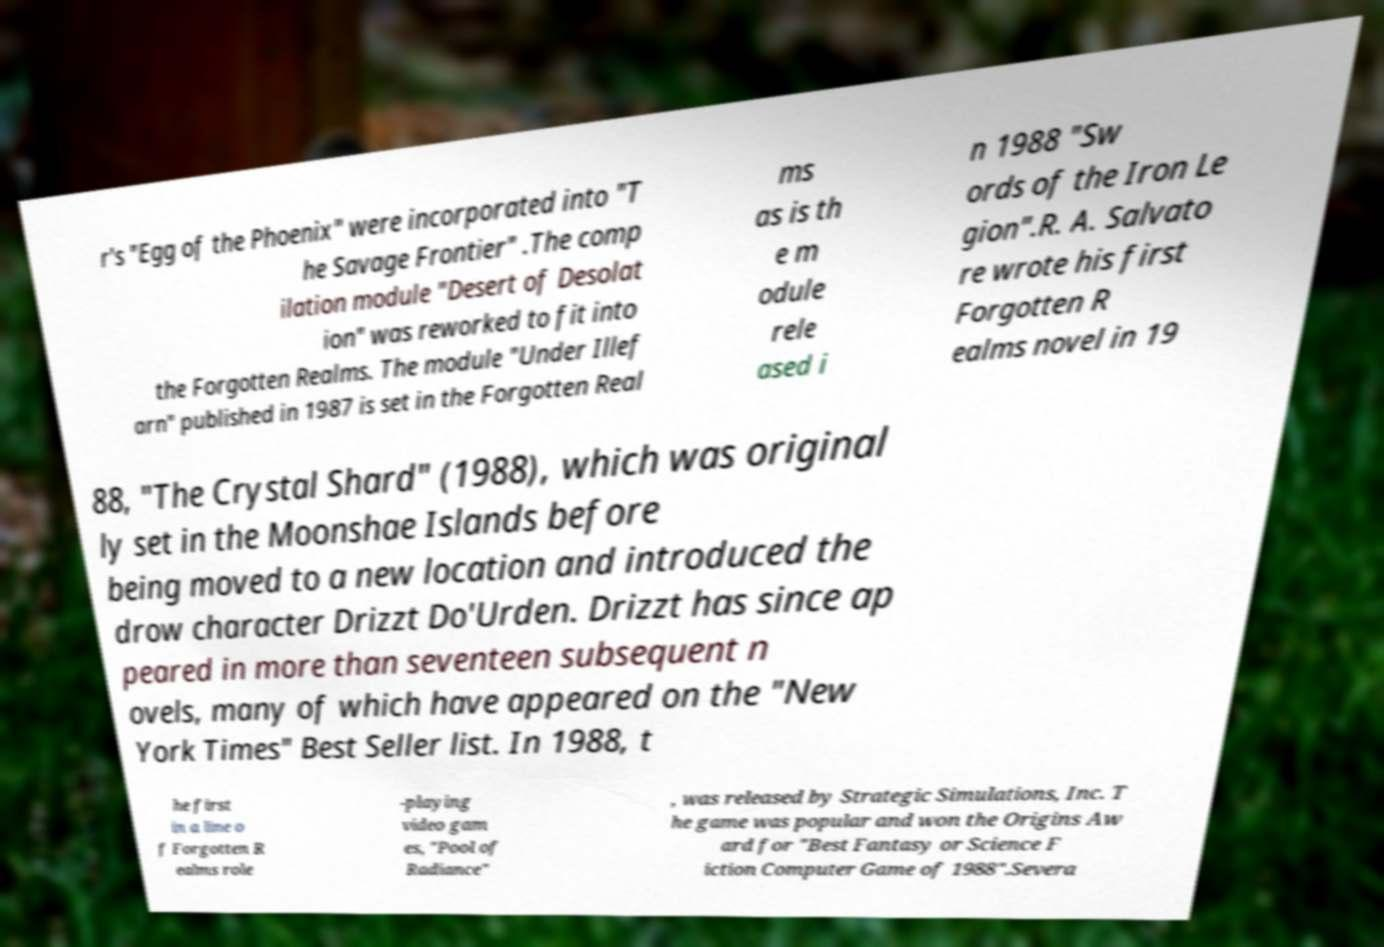Please identify and transcribe the text found in this image. r's "Egg of the Phoenix" were incorporated into "T he Savage Frontier" .The comp ilation module "Desert of Desolat ion" was reworked to fit into the Forgotten Realms. The module "Under Illef arn" published in 1987 is set in the Forgotten Real ms as is th e m odule rele ased i n 1988 "Sw ords of the Iron Le gion".R. A. Salvato re wrote his first Forgotten R ealms novel in 19 88, "The Crystal Shard" (1988), which was original ly set in the Moonshae Islands before being moved to a new location and introduced the drow character Drizzt Do'Urden. Drizzt has since ap peared in more than seventeen subsequent n ovels, many of which have appeared on the "New York Times" Best Seller list. In 1988, t he first in a line o f Forgotten R ealms role -playing video gam es, "Pool of Radiance" , was released by Strategic Simulations, Inc. T he game was popular and won the Origins Aw ard for "Best Fantasy or Science F iction Computer Game of 1988".Severa 